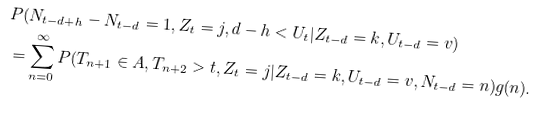Convert formula to latex. <formula><loc_0><loc_0><loc_500><loc_500>& P ( N _ { t - d + h } - N _ { t - d } = 1 , Z _ { t } = j , d - h < U _ { t } | Z _ { t - d } = k , U _ { t - d } = v ) \\ & = \sum _ { n = 0 } ^ { \infty } P ( T _ { n + 1 } \in A , T _ { n + 2 } > t , Z _ { t } = j | Z _ { t - d } = k , U _ { t - d } = v , N _ { t - d } = n ) g ( n ) .</formula> 